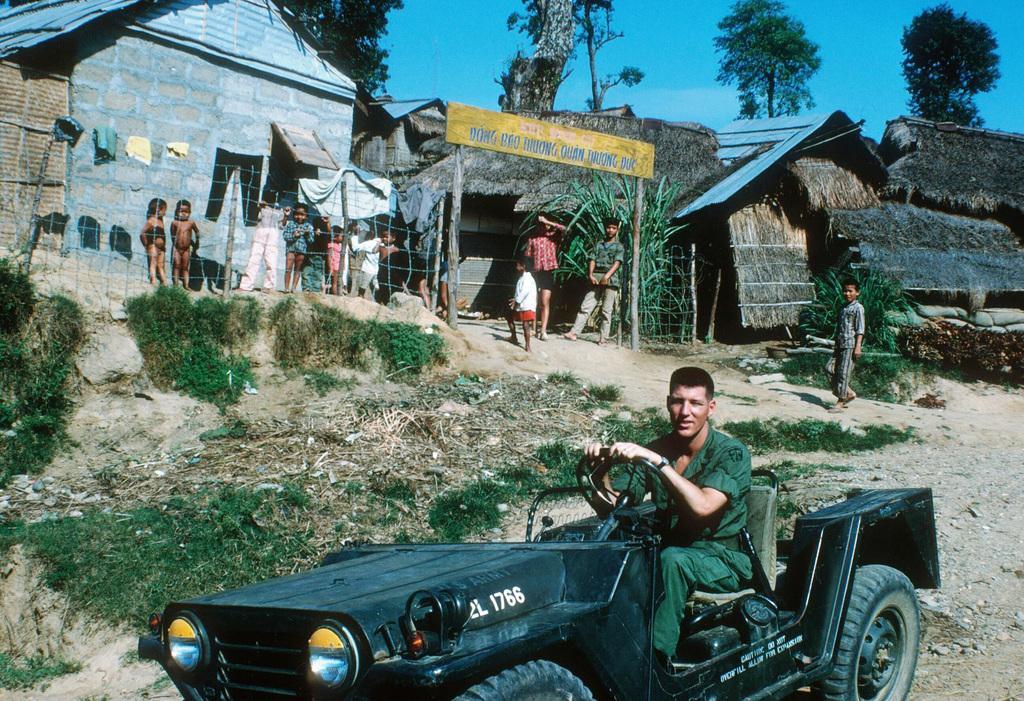Can you describe this image briefly? In this image the person is driving a car. At the back side few people are standing. There is arch. There are houses and a tree. 